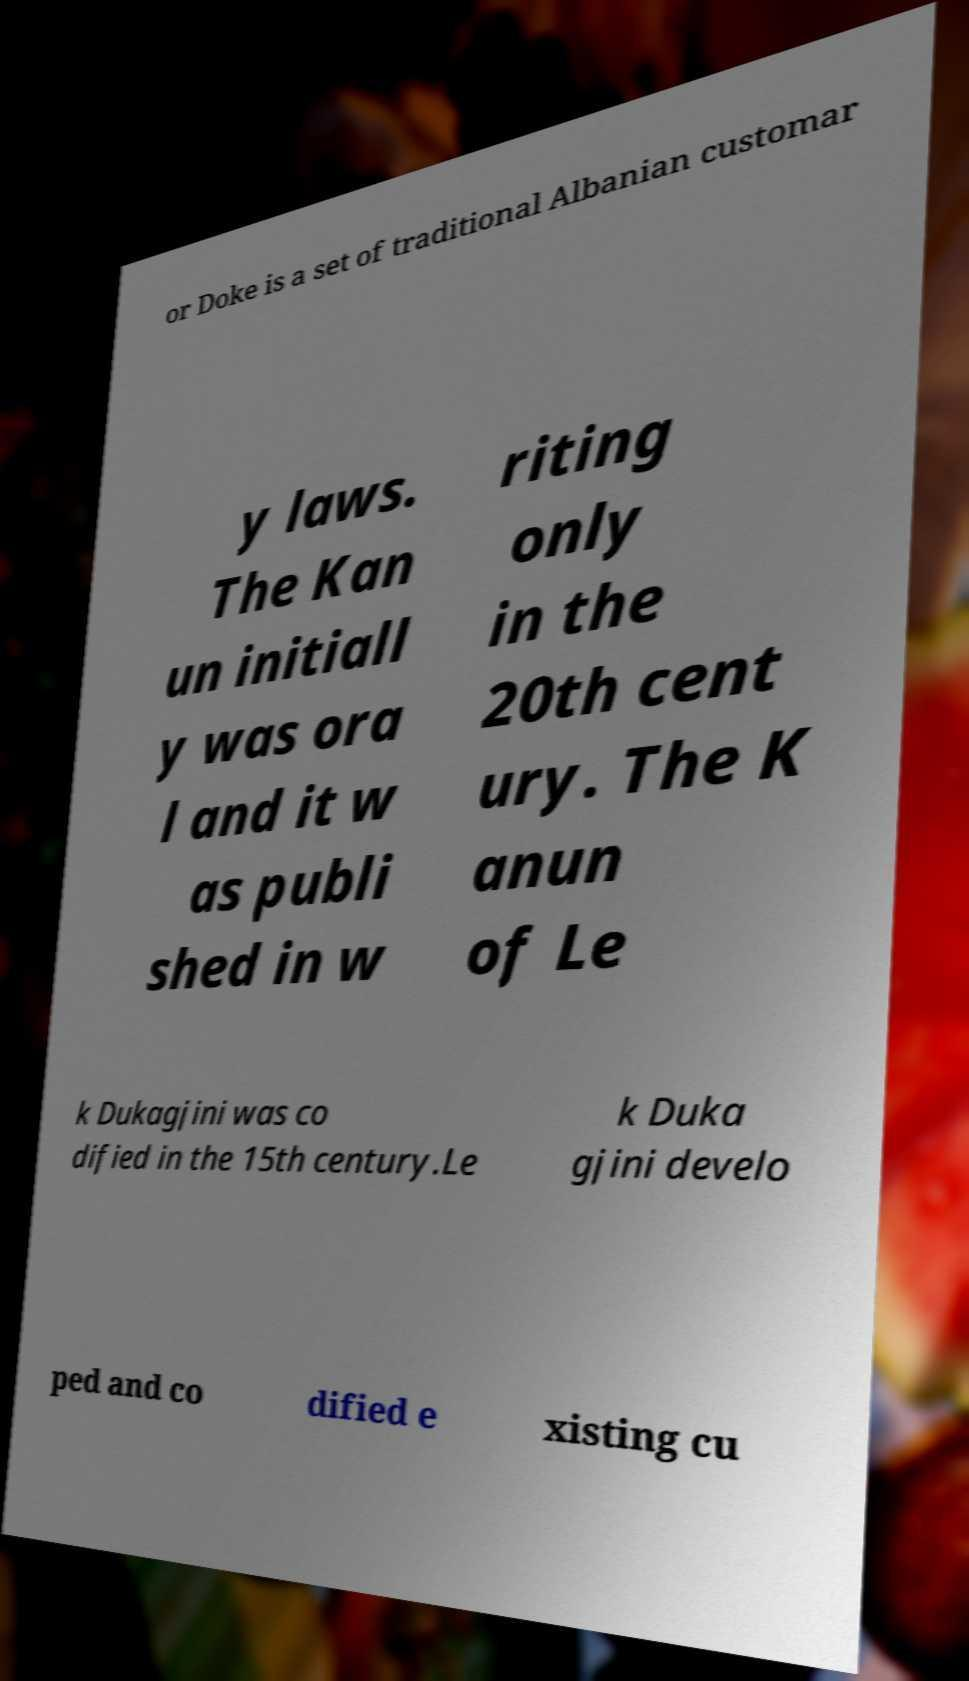Can you accurately transcribe the text from the provided image for me? or Doke is a set of traditional Albanian customar y laws. The Kan un initiall y was ora l and it w as publi shed in w riting only in the 20th cent ury. The K anun of Le k Dukagjini was co dified in the 15th century.Le k Duka gjini develo ped and co dified e xisting cu 